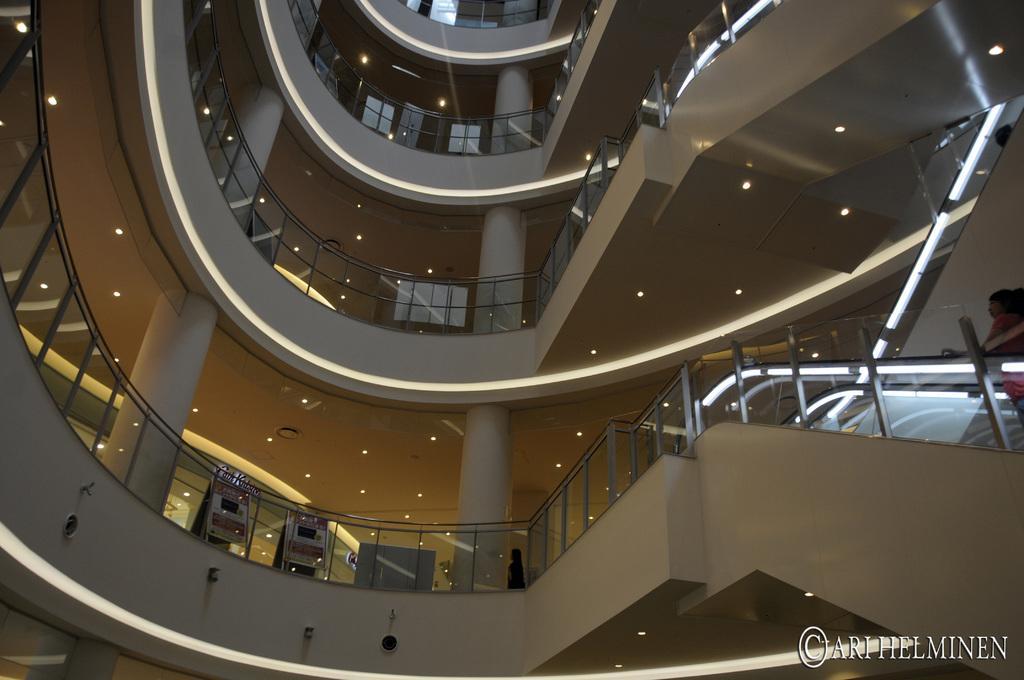In one or two sentences, can you explain what this image depicts? This picture is an inside view of a building. In this picture we can see the wall, pillars, railing, roofs, lights. In the center of the image we can see the machines, board and a person is standing. On the right side of the image we can see the stairs, lights and a person is standing. In the bottom right corner we can see the text. 